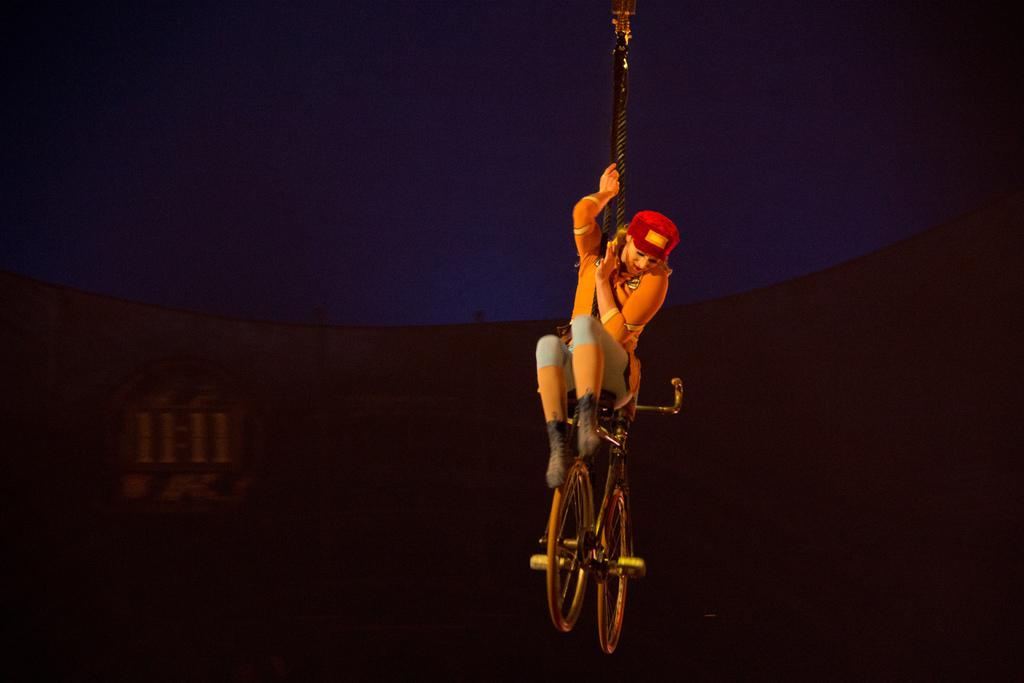Who is present in the image? There is a woman in the image. Where is the woman located? The woman is in the sky. What is the woman sitting on? The woman is sitting on a cycle. What is the woman holding? The woman is holding a rope. How many girls are playing with the dog under the lamp in the image? There are no girls, dogs, or lamps present in the image; it features a woman in the sky holding a rope while sitting on a cycle. 